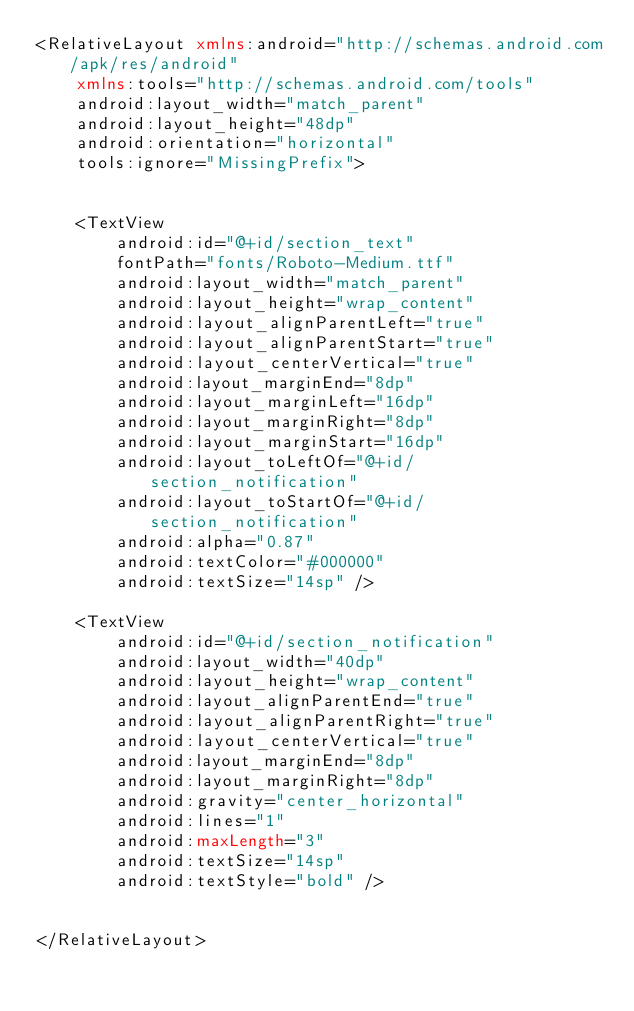Convert code to text. <code><loc_0><loc_0><loc_500><loc_500><_XML_><RelativeLayout xmlns:android="http://schemas.android.com/apk/res/android"
    xmlns:tools="http://schemas.android.com/tools"
    android:layout_width="match_parent"
    android:layout_height="48dp"
    android:orientation="horizontal"
    tools:ignore="MissingPrefix">


    <TextView
        android:id="@+id/section_text"
        fontPath="fonts/Roboto-Medium.ttf"
        android:layout_width="match_parent"
        android:layout_height="wrap_content"
        android:layout_alignParentLeft="true"
        android:layout_alignParentStart="true"
        android:layout_centerVertical="true"
        android:layout_marginEnd="8dp"
        android:layout_marginLeft="16dp"
        android:layout_marginRight="8dp"
        android:layout_marginStart="16dp"
        android:layout_toLeftOf="@+id/section_notification"
        android:layout_toStartOf="@+id/section_notification"
        android:alpha="0.87"
        android:textColor="#000000"
        android:textSize="14sp" />

    <TextView
        android:id="@+id/section_notification"
        android:layout_width="40dp"
        android:layout_height="wrap_content"
        android:layout_alignParentEnd="true"
        android:layout_alignParentRight="true"
        android:layout_centerVertical="true"
        android:layout_marginEnd="8dp"
        android:layout_marginRight="8dp"
        android:gravity="center_horizontal"
        android:lines="1"
        android:maxLength="3"
        android:textSize="14sp"
        android:textStyle="bold" />


</RelativeLayout></code> 